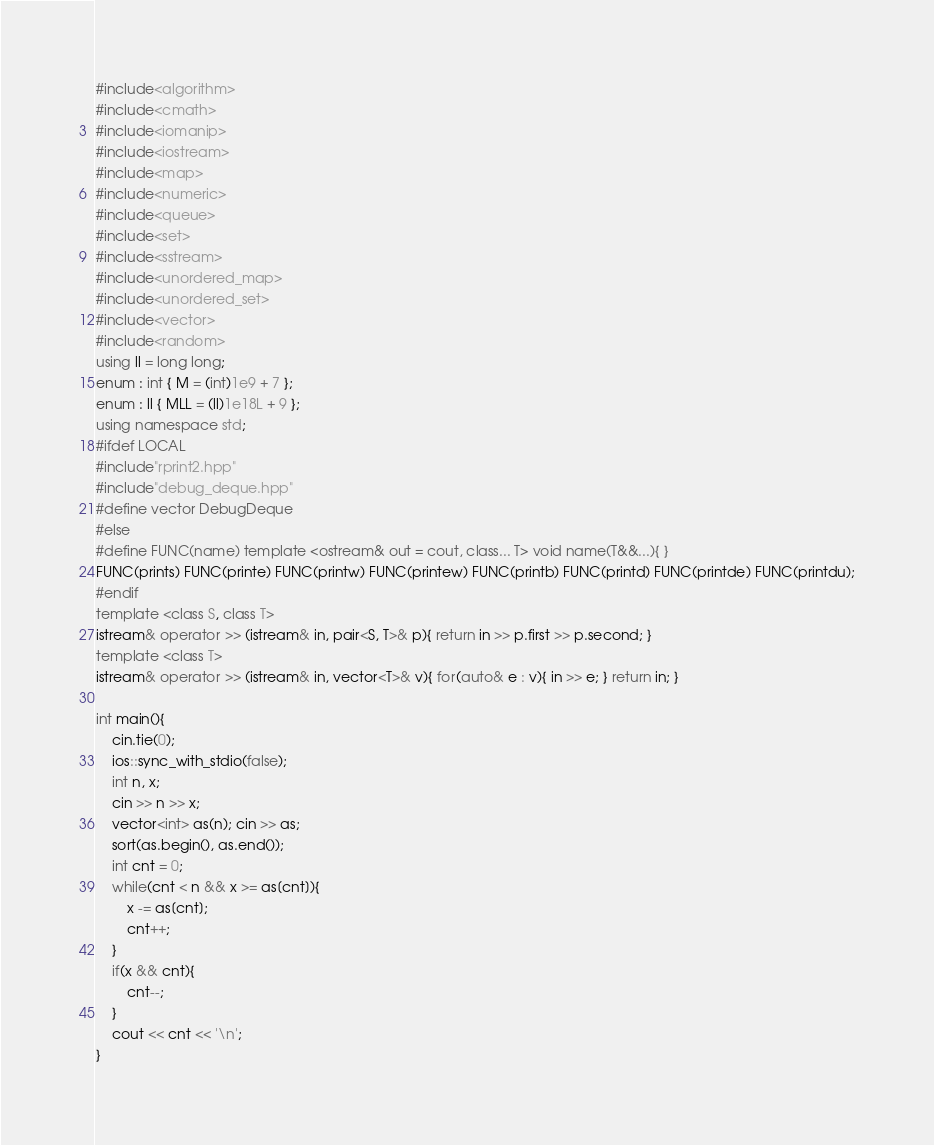Convert code to text. <code><loc_0><loc_0><loc_500><loc_500><_C++_>#include<algorithm>
#include<cmath>
#include<iomanip>
#include<iostream>
#include<map>
#include<numeric>
#include<queue>
#include<set>
#include<sstream>
#include<unordered_map>
#include<unordered_set>
#include<vector>
#include<random>
using ll = long long;
enum : int { M = (int)1e9 + 7 };
enum : ll { MLL = (ll)1e18L + 9 };
using namespace std;
#ifdef LOCAL
#include"rprint2.hpp"
#include"debug_deque.hpp"
#define vector DebugDeque
#else
#define FUNC(name) template <ostream& out = cout, class... T> void name(T&&...){ }
FUNC(prints) FUNC(printe) FUNC(printw) FUNC(printew) FUNC(printb) FUNC(printd) FUNC(printde) FUNC(printdu);
#endif
template <class S, class T>
istream& operator >> (istream& in, pair<S, T>& p){ return in >> p.first >> p.second; }
template <class T>
istream& operator >> (istream& in, vector<T>& v){ for(auto& e : v){ in >> e; } return in; }

int main(){
    cin.tie(0);
    ios::sync_with_stdio(false);
    int n, x;
    cin >> n >> x;
    vector<int> as(n); cin >> as;
    sort(as.begin(), as.end());
    int cnt = 0;
    while(cnt < n && x >= as[cnt]){
        x -= as[cnt];
        cnt++;
    }
    if(x && cnt){
        cnt--;
    }
    cout << cnt << '\n';
}
</code> 